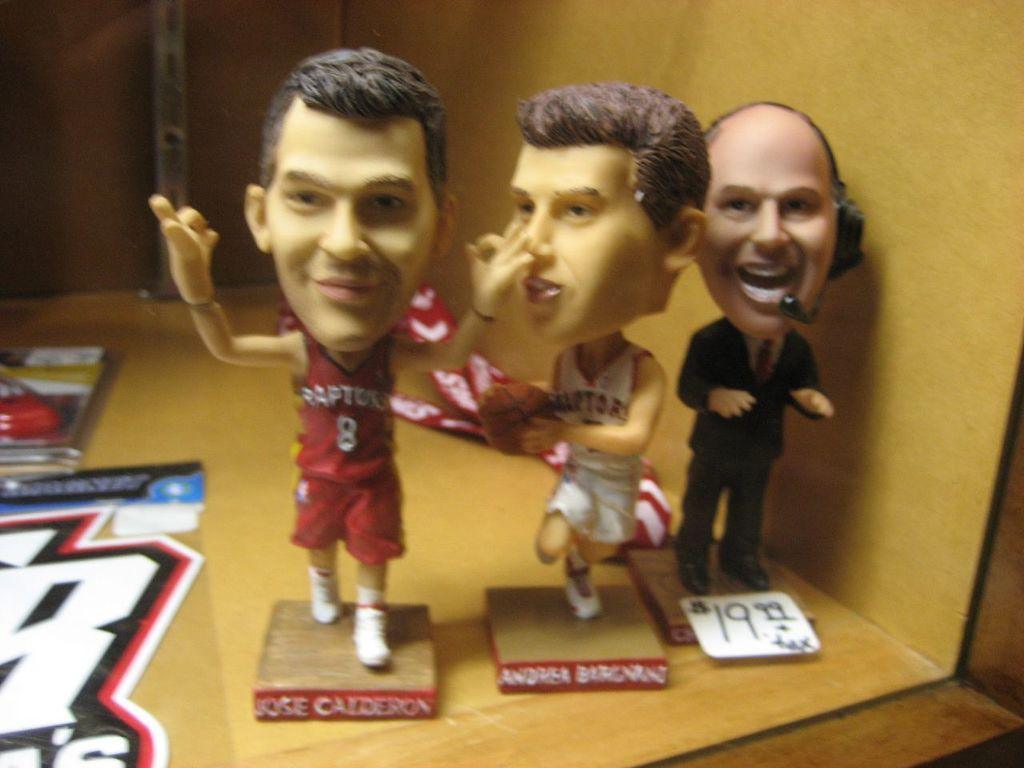What is shown on the wooden surface in the image? There is a depiction of persons on a wooden surface in the image. What can be found in the bottom left corner of the image? There is a sticker in the bottom left of the image. Where are the objects located in the image? The objects are on the left side of the image. Who is the creator of the dock in the image? There is no dock present in the image, so it is not possible to determine the creator. 